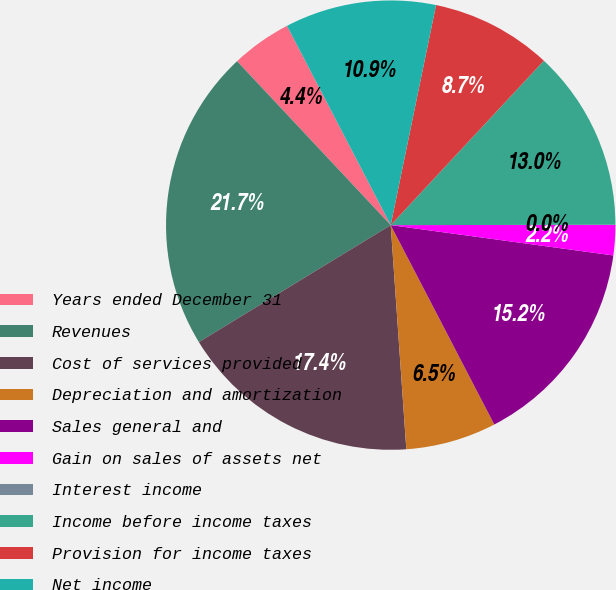<chart> <loc_0><loc_0><loc_500><loc_500><pie_chart><fcel>Years ended December 31<fcel>Revenues<fcel>Cost of services provided<fcel>Depreciation and amortization<fcel>Sales general and<fcel>Gain on sales of assets net<fcel>Interest income<fcel>Income before income taxes<fcel>Provision for income taxes<fcel>Net income<nl><fcel>4.35%<fcel>21.73%<fcel>17.39%<fcel>6.52%<fcel>15.22%<fcel>2.18%<fcel>0.0%<fcel>13.04%<fcel>8.7%<fcel>10.87%<nl></chart> 